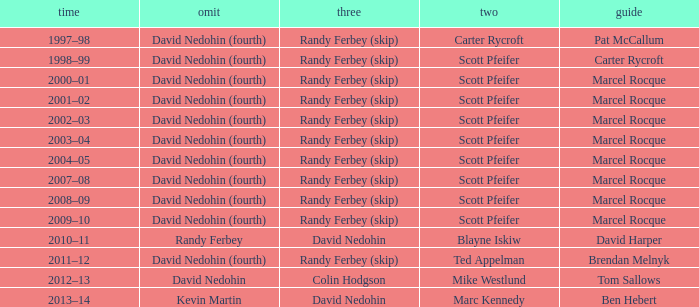Which Third has a Second of scott pfeifer? Randy Ferbey (skip), Randy Ferbey (skip), Randy Ferbey (skip), Randy Ferbey (skip), Randy Ferbey (skip), Randy Ferbey (skip), Randy Ferbey (skip), Randy Ferbey (skip), Randy Ferbey (skip). Could you parse the entire table? {'header': ['time', 'omit', 'three', 'two', 'guide'], 'rows': [['1997–98', 'David Nedohin (fourth)', 'Randy Ferbey (skip)', 'Carter Rycroft', 'Pat McCallum'], ['1998–99', 'David Nedohin (fourth)', 'Randy Ferbey (skip)', 'Scott Pfeifer', 'Carter Rycroft'], ['2000–01', 'David Nedohin (fourth)', 'Randy Ferbey (skip)', 'Scott Pfeifer', 'Marcel Rocque'], ['2001–02', 'David Nedohin (fourth)', 'Randy Ferbey (skip)', 'Scott Pfeifer', 'Marcel Rocque'], ['2002–03', 'David Nedohin (fourth)', 'Randy Ferbey (skip)', 'Scott Pfeifer', 'Marcel Rocque'], ['2003–04', 'David Nedohin (fourth)', 'Randy Ferbey (skip)', 'Scott Pfeifer', 'Marcel Rocque'], ['2004–05', 'David Nedohin (fourth)', 'Randy Ferbey (skip)', 'Scott Pfeifer', 'Marcel Rocque'], ['2007–08', 'David Nedohin (fourth)', 'Randy Ferbey (skip)', 'Scott Pfeifer', 'Marcel Rocque'], ['2008–09', 'David Nedohin (fourth)', 'Randy Ferbey (skip)', 'Scott Pfeifer', 'Marcel Rocque'], ['2009–10', 'David Nedohin (fourth)', 'Randy Ferbey (skip)', 'Scott Pfeifer', 'Marcel Rocque'], ['2010–11', 'Randy Ferbey', 'David Nedohin', 'Blayne Iskiw', 'David Harper'], ['2011–12', 'David Nedohin (fourth)', 'Randy Ferbey (skip)', 'Ted Appelman', 'Brendan Melnyk'], ['2012–13', 'David Nedohin', 'Colin Hodgson', 'Mike Westlund', 'Tom Sallows'], ['2013–14', 'Kevin Martin', 'David Nedohin', 'Marc Kennedy', 'Ben Hebert']]} 